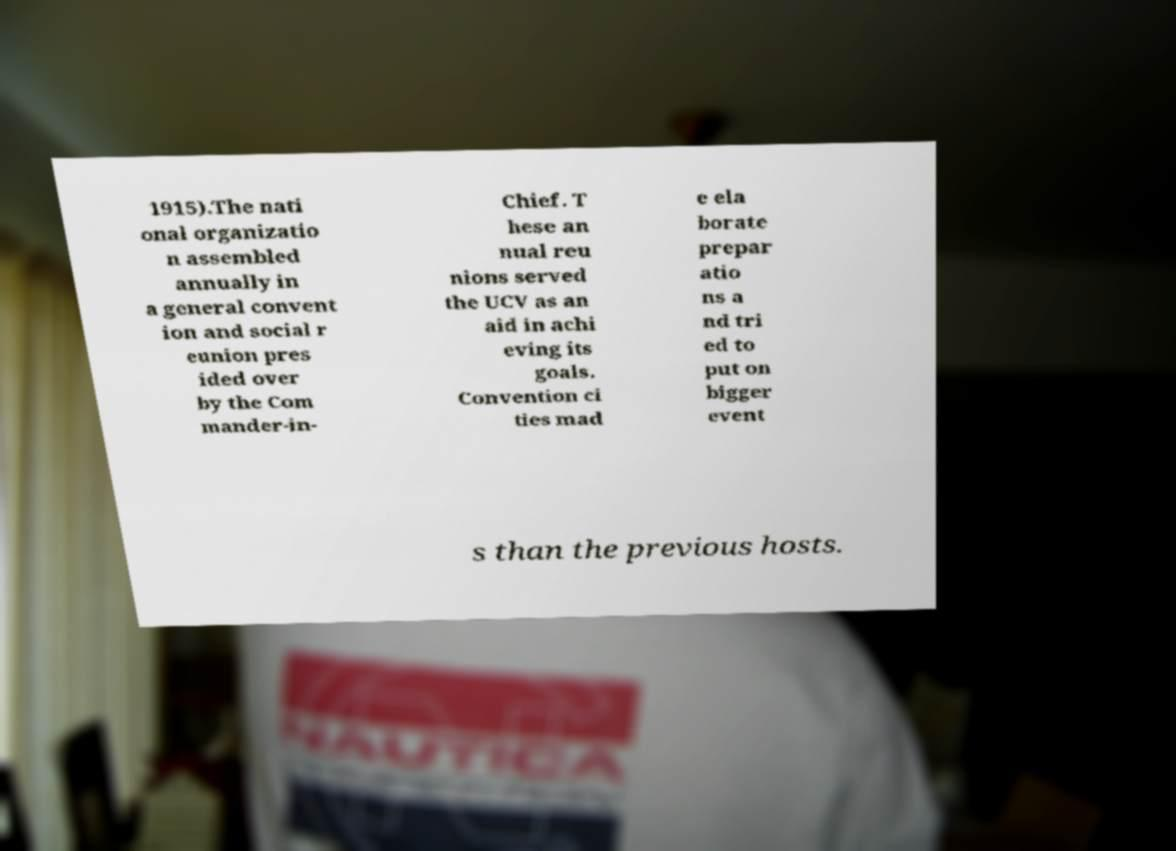I need the written content from this picture converted into text. Can you do that? 1915).The nati onal organizatio n assembled annually in a general convent ion and social r eunion pres ided over by the Com mander-in- Chief. T hese an nual reu nions served the UCV as an aid in achi eving its goals. Convention ci ties mad e ela borate prepar atio ns a nd tri ed to put on bigger event s than the previous hosts. 